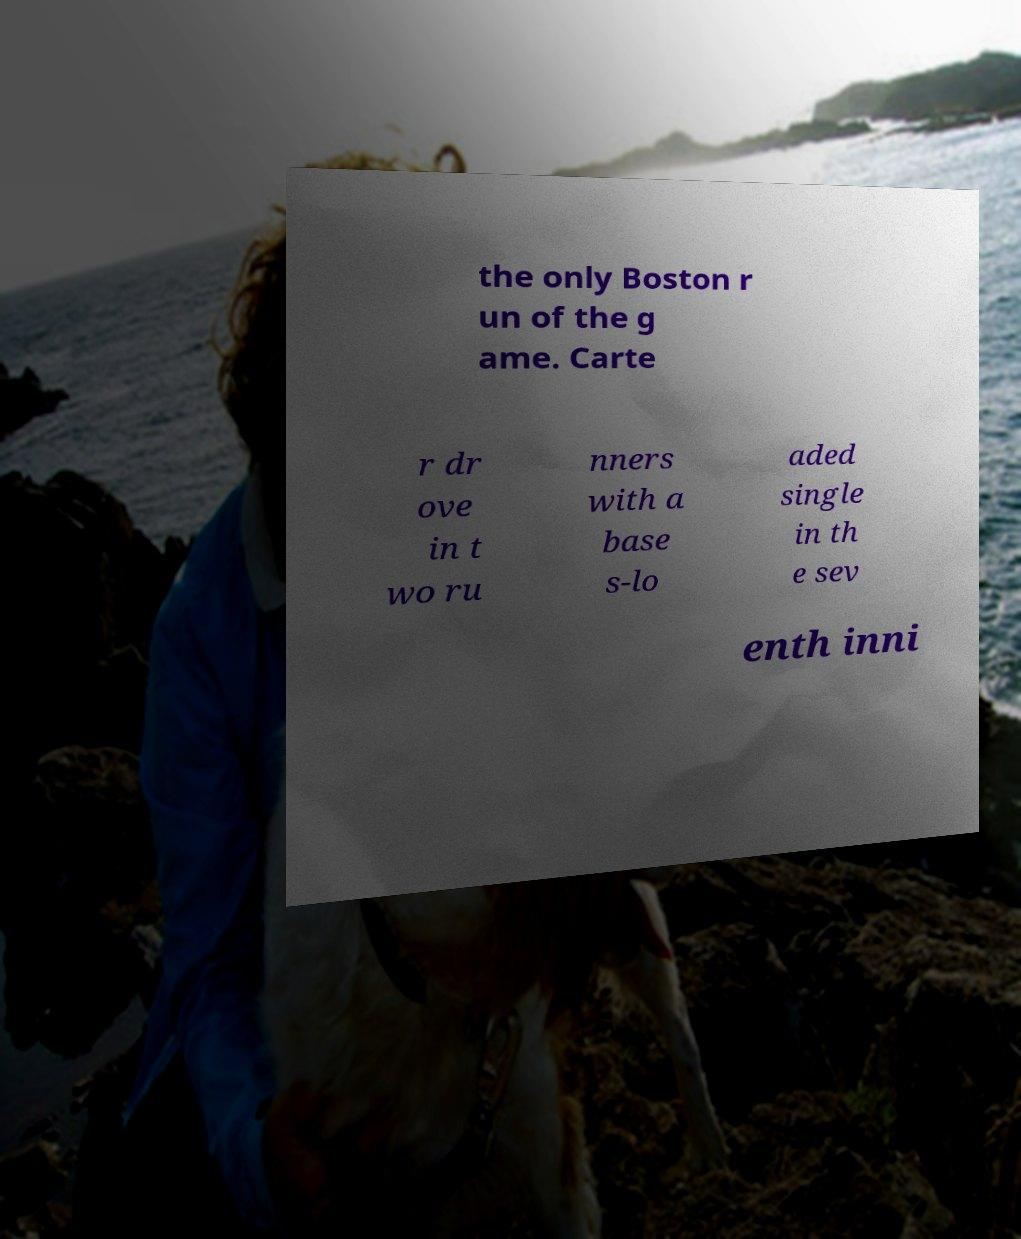What messages or text are displayed in this image? I need them in a readable, typed format. the only Boston r un of the g ame. Carte r dr ove in t wo ru nners with a base s-lo aded single in th e sev enth inni 